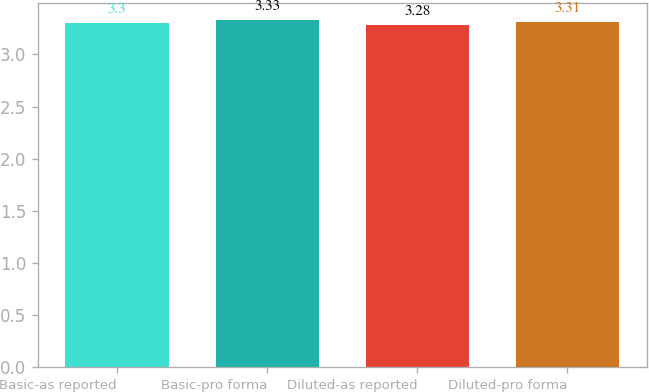<chart> <loc_0><loc_0><loc_500><loc_500><bar_chart><fcel>Basic-as reported<fcel>Basic-pro forma<fcel>Diluted-as reported<fcel>Diluted-pro forma<nl><fcel>3.3<fcel>3.33<fcel>3.28<fcel>3.31<nl></chart> 